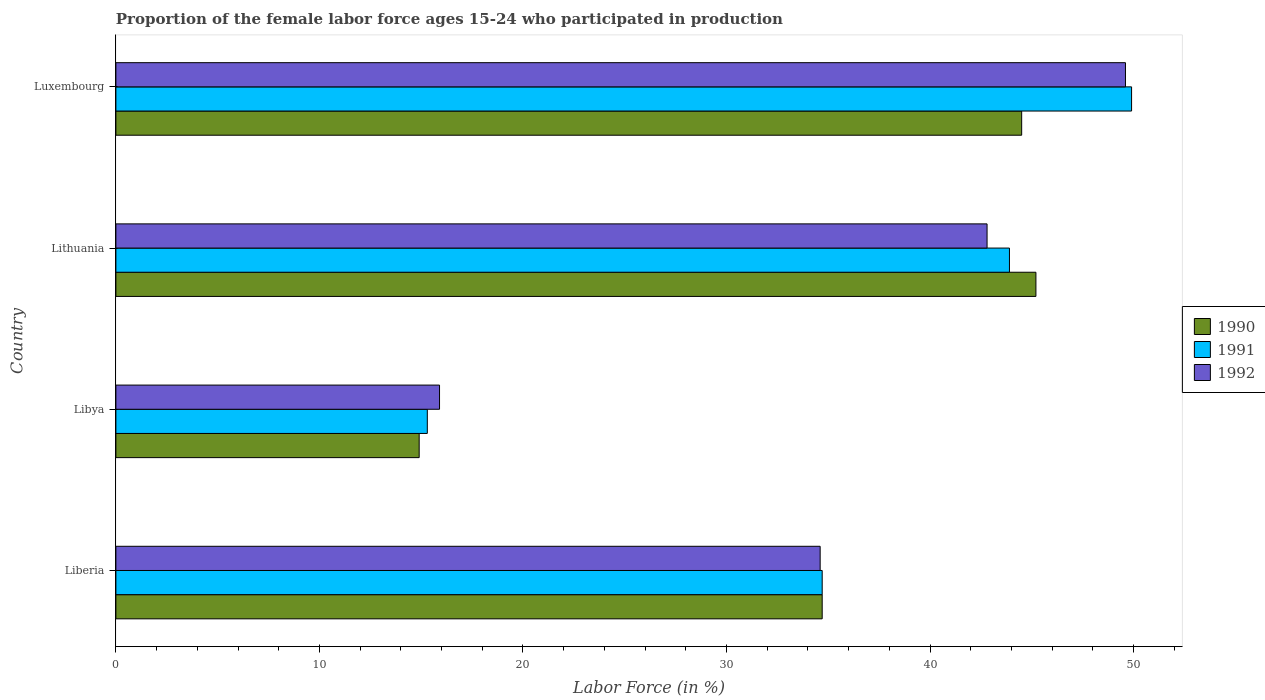How many groups of bars are there?
Keep it short and to the point. 4. How many bars are there on the 1st tick from the top?
Make the answer very short. 3. How many bars are there on the 2nd tick from the bottom?
Your response must be concise. 3. What is the label of the 4th group of bars from the top?
Make the answer very short. Liberia. In how many cases, is the number of bars for a given country not equal to the number of legend labels?
Make the answer very short. 0. What is the proportion of the female labor force who participated in production in 1992 in Libya?
Ensure brevity in your answer.  15.9. Across all countries, what is the maximum proportion of the female labor force who participated in production in 1992?
Offer a very short reply. 49.6. Across all countries, what is the minimum proportion of the female labor force who participated in production in 1990?
Ensure brevity in your answer.  14.9. In which country was the proportion of the female labor force who participated in production in 1992 maximum?
Your answer should be very brief. Luxembourg. In which country was the proportion of the female labor force who participated in production in 1992 minimum?
Your answer should be very brief. Libya. What is the total proportion of the female labor force who participated in production in 1991 in the graph?
Offer a terse response. 143.8. What is the difference between the proportion of the female labor force who participated in production in 1991 in Liberia and that in Lithuania?
Give a very brief answer. -9.2. What is the difference between the proportion of the female labor force who participated in production in 1990 in Liberia and the proportion of the female labor force who participated in production in 1991 in Lithuania?
Offer a very short reply. -9.2. What is the average proportion of the female labor force who participated in production in 1991 per country?
Offer a very short reply. 35.95. What is the difference between the proportion of the female labor force who participated in production in 1992 and proportion of the female labor force who participated in production in 1991 in Luxembourg?
Offer a very short reply. -0.3. In how many countries, is the proportion of the female labor force who participated in production in 1990 greater than 34 %?
Give a very brief answer. 3. What is the ratio of the proportion of the female labor force who participated in production in 1992 in Liberia to that in Lithuania?
Your response must be concise. 0.81. Is the difference between the proportion of the female labor force who participated in production in 1992 in Libya and Luxembourg greater than the difference between the proportion of the female labor force who participated in production in 1991 in Libya and Luxembourg?
Give a very brief answer. Yes. What is the difference between the highest and the second highest proportion of the female labor force who participated in production in 1990?
Make the answer very short. 0.7. What is the difference between the highest and the lowest proportion of the female labor force who participated in production in 1990?
Give a very brief answer. 30.3. In how many countries, is the proportion of the female labor force who participated in production in 1990 greater than the average proportion of the female labor force who participated in production in 1990 taken over all countries?
Ensure brevity in your answer.  2. How many bars are there?
Offer a very short reply. 12. Are the values on the major ticks of X-axis written in scientific E-notation?
Provide a succinct answer. No. What is the title of the graph?
Ensure brevity in your answer.  Proportion of the female labor force ages 15-24 who participated in production. Does "1990" appear as one of the legend labels in the graph?
Your answer should be compact. Yes. What is the label or title of the Y-axis?
Ensure brevity in your answer.  Country. What is the Labor Force (in %) of 1990 in Liberia?
Your response must be concise. 34.7. What is the Labor Force (in %) in 1991 in Liberia?
Keep it short and to the point. 34.7. What is the Labor Force (in %) of 1992 in Liberia?
Provide a short and direct response. 34.6. What is the Labor Force (in %) in 1990 in Libya?
Your answer should be compact. 14.9. What is the Labor Force (in %) in 1991 in Libya?
Offer a terse response. 15.3. What is the Labor Force (in %) in 1992 in Libya?
Offer a terse response. 15.9. What is the Labor Force (in %) in 1990 in Lithuania?
Your response must be concise. 45.2. What is the Labor Force (in %) in 1991 in Lithuania?
Your answer should be compact. 43.9. What is the Labor Force (in %) of 1992 in Lithuania?
Your answer should be very brief. 42.8. What is the Labor Force (in %) in 1990 in Luxembourg?
Offer a very short reply. 44.5. What is the Labor Force (in %) in 1991 in Luxembourg?
Ensure brevity in your answer.  49.9. What is the Labor Force (in %) of 1992 in Luxembourg?
Your answer should be compact. 49.6. Across all countries, what is the maximum Labor Force (in %) of 1990?
Your answer should be compact. 45.2. Across all countries, what is the maximum Labor Force (in %) of 1991?
Ensure brevity in your answer.  49.9. Across all countries, what is the maximum Labor Force (in %) of 1992?
Give a very brief answer. 49.6. Across all countries, what is the minimum Labor Force (in %) of 1990?
Offer a terse response. 14.9. Across all countries, what is the minimum Labor Force (in %) in 1991?
Your answer should be very brief. 15.3. Across all countries, what is the minimum Labor Force (in %) in 1992?
Give a very brief answer. 15.9. What is the total Labor Force (in %) of 1990 in the graph?
Give a very brief answer. 139.3. What is the total Labor Force (in %) of 1991 in the graph?
Provide a succinct answer. 143.8. What is the total Labor Force (in %) in 1992 in the graph?
Keep it short and to the point. 142.9. What is the difference between the Labor Force (in %) in 1990 in Liberia and that in Libya?
Your answer should be compact. 19.8. What is the difference between the Labor Force (in %) of 1991 in Liberia and that in Libya?
Your response must be concise. 19.4. What is the difference between the Labor Force (in %) in 1992 in Liberia and that in Libya?
Provide a short and direct response. 18.7. What is the difference between the Labor Force (in %) in 1990 in Liberia and that in Lithuania?
Ensure brevity in your answer.  -10.5. What is the difference between the Labor Force (in %) in 1992 in Liberia and that in Lithuania?
Provide a succinct answer. -8.2. What is the difference between the Labor Force (in %) in 1991 in Liberia and that in Luxembourg?
Provide a short and direct response. -15.2. What is the difference between the Labor Force (in %) in 1990 in Libya and that in Lithuania?
Keep it short and to the point. -30.3. What is the difference between the Labor Force (in %) of 1991 in Libya and that in Lithuania?
Ensure brevity in your answer.  -28.6. What is the difference between the Labor Force (in %) of 1992 in Libya and that in Lithuania?
Your answer should be compact. -26.9. What is the difference between the Labor Force (in %) of 1990 in Libya and that in Luxembourg?
Your response must be concise. -29.6. What is the difference between the Labor Force (in %) of 1991 in Libya and that in Luxembourg?
Keep it short and to the point. -34.6. What is the difference between the Labor Force (in %) of 1992 in Libya and that in Luxembourg?
Your answer should be compact. -33.7. What is the difference between the Labor Force (in %) of 1990 in Lithuania and that in Luxembourg?
Ensure brevity in your answer.  0.7. What is the difference between the Labor Force (in %) in 1992 in Lithuania and that in Luxembourg?
Make the answer very short. -6.8. What is the difference between the Labor Force (in %) of 1990 in Liberia and the Labor Force (in %) of 1991 in Libya?
Your response must be concise. 19.4. What is the difference between the Labor Force (in %) of 1991 in Liberia and the Labor Force (in %) of 1992 in Libya?
Give a very brief answer. 18.8. What is the difference between the Labor Force (in %) of 1991 in Liberia and the Labor Force (in %) of 1992 in Lithuania?
Provide a succinct answer. -8.1. What is the difference between the Labor Force (in %) of 1990 in Liberia and the Labor Force (in %) of 1991 in Luxembourg?
Give a very brief answer. -15.2. What is the difference between the Labor Force (in %) in 1990 in Liberia and the Labor Force (in %) in 1992 in Luxembourg?
Make the answer very short. -14.9. What is the difference between the Labor Force (in %) in 1991 in Liberia and the Labor Force (in %) in 1992 in Luxembourg?
Provide a short and direct response. -14.9. What is the difference between the Labor Force (in %) in 1990 in Libya and the Labor Force (in %) in 1991 in Lithuania?
Your answer should be very brief. -29. What is the difference between the Labor Force (in %) in 1990 in Libya and the Labor Force (in %) in 1992 in Lithuania?
Your response must be concise. -27.9. What is the difference between the Labor Force (in %) of 1991 in Libya and the Labor Force (in %) of 1992 in Lithuania?
Give a very brief answer. -27.5. What is the difference between the Labor Force (in %) of 1990 in Libya and the Labor Force (in %) of 1991 in Luxembourg?
Your answer should be very brief. -35. What is the difference between the Labor Force (in %) in 1990 in Libya and the Labor Force (in %) in 1992 in Luxembourg?
Provide a succinct answer. -34.7. What is the difference between the Labor Force (in %) of 1991 in Libya and the Labor Force (in %) of 1992 in Luxembourg?
Give a very brief answer. -34.3. What is the difference between the Labor Force (in %) of 1990 in Lithuania and the Labor Force (in %) of 1992 in Luxembourg?
Your answer should be very brief. -4.4. What is the difference between the Labor Force (in %) of 1991 in Lithuania and the Labor Force (in %) of 1992 in Luxembourg?
Make the answer very short. -5.7. What is the average Labor Force (in %) in 1990 per country?
Ensure brevity in your answer.  34.83. What is the average Labor Force (in %) in 1991 per country?
Your answer should be compact. 35.95. What is the average Labor Force (in %) in 1992 per country?
Provide a short and direct response. 35.73. What is the difference between the Labor Force (in %) of 1991 and Labor Force (in %) of 1992 in Liberia?
Ensure brevity in your answer.  0.1. What is the difference between the Labor Force (in %) in 1990 and Labor Force (in %) in 1991 in Libya?
Provide a short and direct response. -0.4. What is the difference between the Labor Force (in %) of 1991 and Labor Force (in %) of 1992 in Libya?
Your response must be concise. -0.6. What is the difference between the Labor Force (in %) in 1990 and Labor Force (in %) in 1991 in Luxembourg?
Ensure brevity in your answer.  -5.4. What is the difference between the Labor Force (in %) in 1990 and Labor Force (in %) in 1992 in Luxembourg?
Give a very brief answer. -5.1. What is the difference between the Labor Force (in %) of 1991 and Labor Force (in %) of 1992 in Luxembourg?
Ensure brevity in your answer.  0.3. What is the ratio of the Labor Force (in %) of 1990 in Liberia to that in Libya?
Keep it short and to the point. 2.33. What is the ratio of the Labor Force (in %) of 1991 in Liberia to that in Libya?
Provide a short and direct response. 2.27. What is the ratio of the Labor Force (in %) of 1992 in Liberia to that in Libya?
Your answer should be compact. 2.18. What is the ratio of the Labor Force (in %) in 1990 in Liberia to that in Lithuania?
Make the answer very short. 0.77. What is the ratio of the Labor Force (in %) in 1991 in Liberia to that in Lithuania?
Your answer should be very brief. 0.79. What is the ratio of the Labor Force (in %) in 1992 in Liberia to that in Lithuania?
Keep it short and to the point. 0.81. What is the ratio of the Labor Force (in %) of 1990 in Liberia to that in Luxembourg?
Your response must be concise. 0.78. What is the ratio of the Labor Force (in %) in 1991 in Liberia to that in Luxembourg?
Keep it short and to the point. 0.7. What is the ratio of the Labor Force (in %) in 1992 in Liberia to that in Luxembourg?
Make the answer very short. 0.7. What is the ratio of the Labor Force (in %) of 1990 in Libya to that in Lithuania?
Your response must be concise. 0.33. What is the ratio of the Labor Force (in %) in 1991 in Libya to that in Lithuania?
Your answer should be compact. 0.35. What is the ratio of the Labor Force (in %) of 1992 in Libya to that in Lithuania?
Your answer should be compact. 0.37. What is the ratio of the Labor Force (in %) in 1990 in Libya to that in Luxembourg?
Provide a succinct answer. 0.33. What is the ratio of the Labor Force (in %) of 1991 in Libya to that in Luxembourg?
Your answer should be compact. 0.31. What is the ratio of the Labor Force (in %) of 1992 in Libya to that in Luxembourg?
Your response must be concise. 0.32. What is the ratio of the Labor Force (in %) in 1990 in Lithuania to that in Luxembourg?
Make the answer very short. 1.02. What is the ratio of the Labor Force (in %) of 1991 in Lithuania to that in Luxembourg?
Offer a terse response. 0.88. What is the ratio of the Labor Force (in %) of 1992 in Lithuania to that in Luxembourg?
Your answer should be compact. 0.86. What is the difference between the highest and the second highest Labor Force (in %) of 1991?
Offer a terse response. 6. What is the difference between the highest and the lowest Labor Force (in %) of 1990?
Ensure brevity in your answer.  30.3. What is the difference between the highest and the lowest Labor Force (in %) of 1991?
Offer a very short reply. 34.6. What is the difference between the highest and the lowest Labor Force (in %) in 1992?
Your answer should be compact. 33.7. 